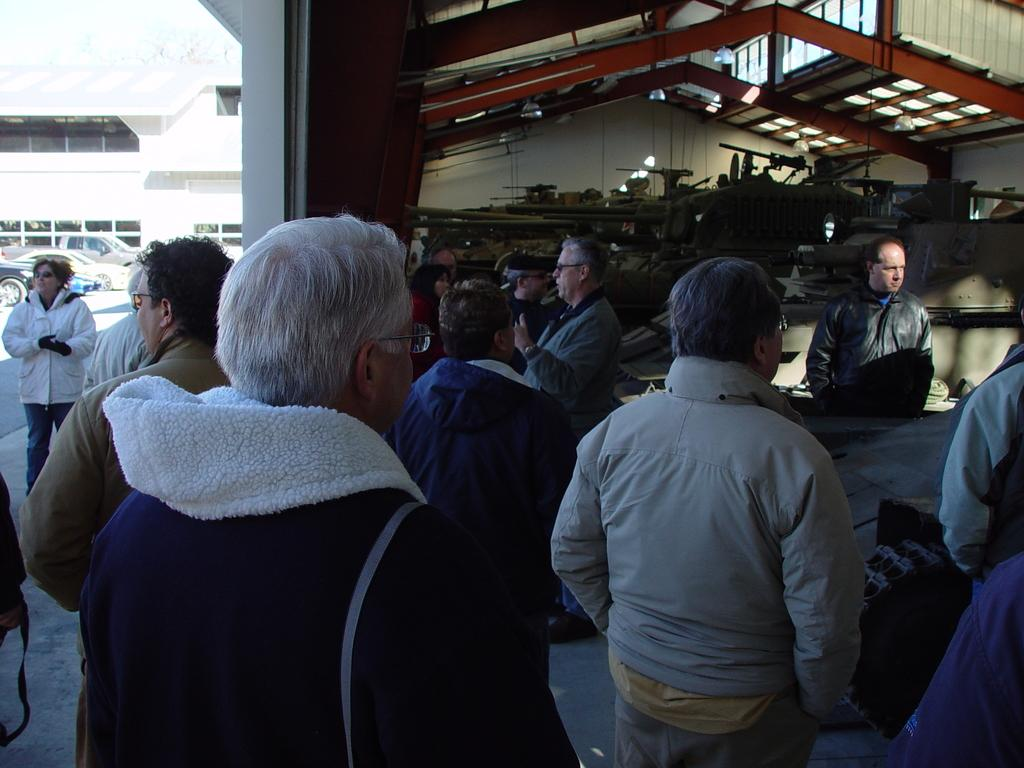What is happening in the image? There are people standing in the image. What can be seen in the background of the image? There are vehicles and at least one building in the background of the image. What architectural feature is present in the background of the image? There is a wall in the background of the image. Can you see any muscles flexing in the image? There is no indication of muscles flexing in the image; it features people standing and background elements. 